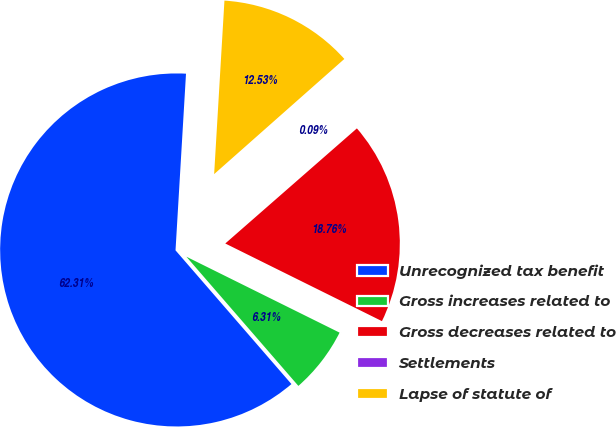<chart> <loc_0><loc_0><loc_500><loc_500><pie_chart><fcel>Unrecognized tax benefit<fcel>Gross increases related to<fcel>Gross decreases related to<fcel>Settlements<fcel>Lapse of statute of<nl><fcel>62.31%<fcel>6.31%<fcel>18.76%<fcel>0.09%<fcel>12.53%<nl></chart> 